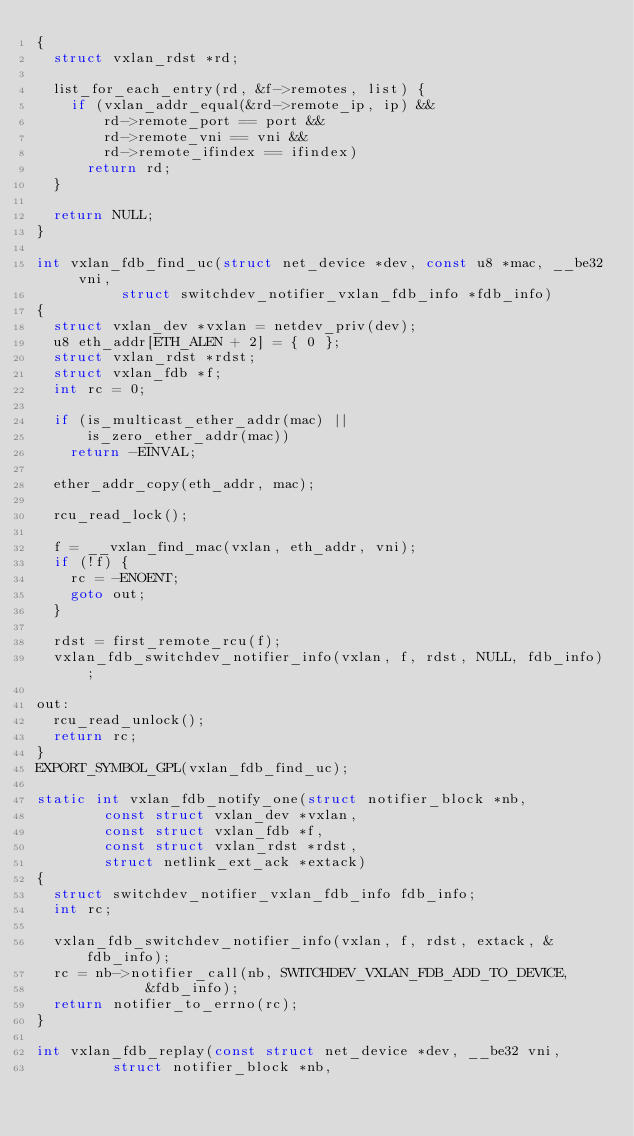<code> <loc_0><loc_0><loc_500><loc_500><_C_>{
	struct vxlan_rdst *rd;

	list_for_each_entry(rd, &f->remotes, list) {
		if (vxlan_addr_equal(&rd->remote_ip, ip) &&
		    rd->remote_port == port &&
		    rd->remote_vni == vni &&
		    rd->remote_ifindex == ifindex)
			return rd;
	}

	return NULL;
}

int vxlan_fdb_find_uc(struct net_device *dev, const u8 *mac, __be32 vni,
		      struct switchdev_notifier_vxlan_fdb_info *fdb_info)
{
	struct vxlan_dev *vxlan = netdev_priv(dev);
	u8 eth_addr[ETH_ALEN + 2] = { 0 };
	struct vxlan_rdst *rdst;
	struct vxlan_fdb *f;
	int rc = 0;

	if (is_multicast_ether_addr(mac) ||
	    is_zero_ether_addr(mac))
		return -EINVAL;

	ether_addr_copy(eth_addr, mac);

	rcu_read_lock();

	f = __vxlan_find_mac(vxlan, eth_addr, vni);
	if (!f) {
		rc = -ENOENT;
		goto out;
	}

	rdst = first_remote_rcu(f);
	vxlan_fdb_switchdev_notifier_info(vxlan, f, rdst, NULL, fdb_info);

out:
	rcu_read_unlock();
	return rc;
}
EXPORT_SYMBOL_GPL(vxlan_fdb_find_uc);

static int vxlan_fdb_notify_one(struct notifier_block *nb,
				const struct vxlan_dev *vxlan,
				const struct vxlan_fdb *f,
				const struct vxlan_rdst *rdst,
				struct netlink_ext_ack *extack)
{
	struct switchdev_notifier_vxlan_fdb_info fdb_info;
	int rc;

	vxlan_fdb_switchdev_notifier_info(vxlan, f, rdst, extack, &fdb_info);
	rc = nb->notifier_call(nb, SWITCHDEV_VXLAN_FDB_ADD_TO_DEVICE,
			       &fdb_info);
	return notifier_to_errno(rc);
}

int vxlan_fdb_replay(const struct net_device *dev, __be32 vni,
		     struct notifier_block *nb,</code> 